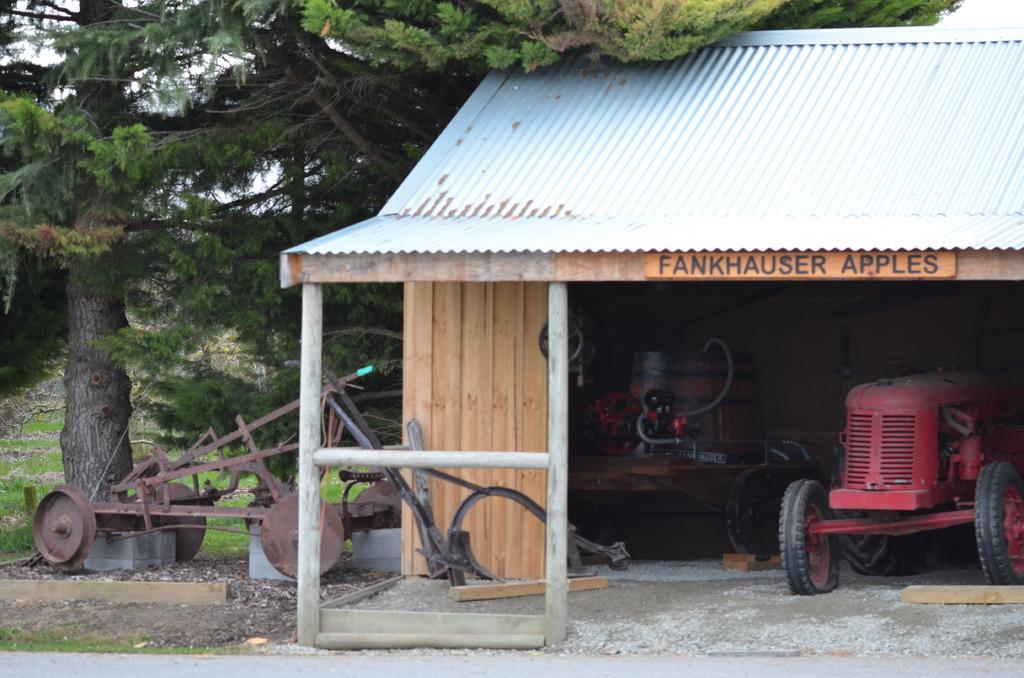What is located under the shed in the image? There is a tractor under the shed in the image. What else can be seen in the foreground area of the image? There are other objects in the foreground area of the image. What type of natural environment is visible in the background of the image? There are trees and grassland in the background of the image. What is visible in the sky in the background of the image? The sky is visible in the background of the image. What type of birthday celebration is taking place in the image? There is no indication of a birthday celebration in the image. Can you tell me the history of the lock on the shed in the image? There is no lock visible on the shed in the image, and therefore no history can be determined. 